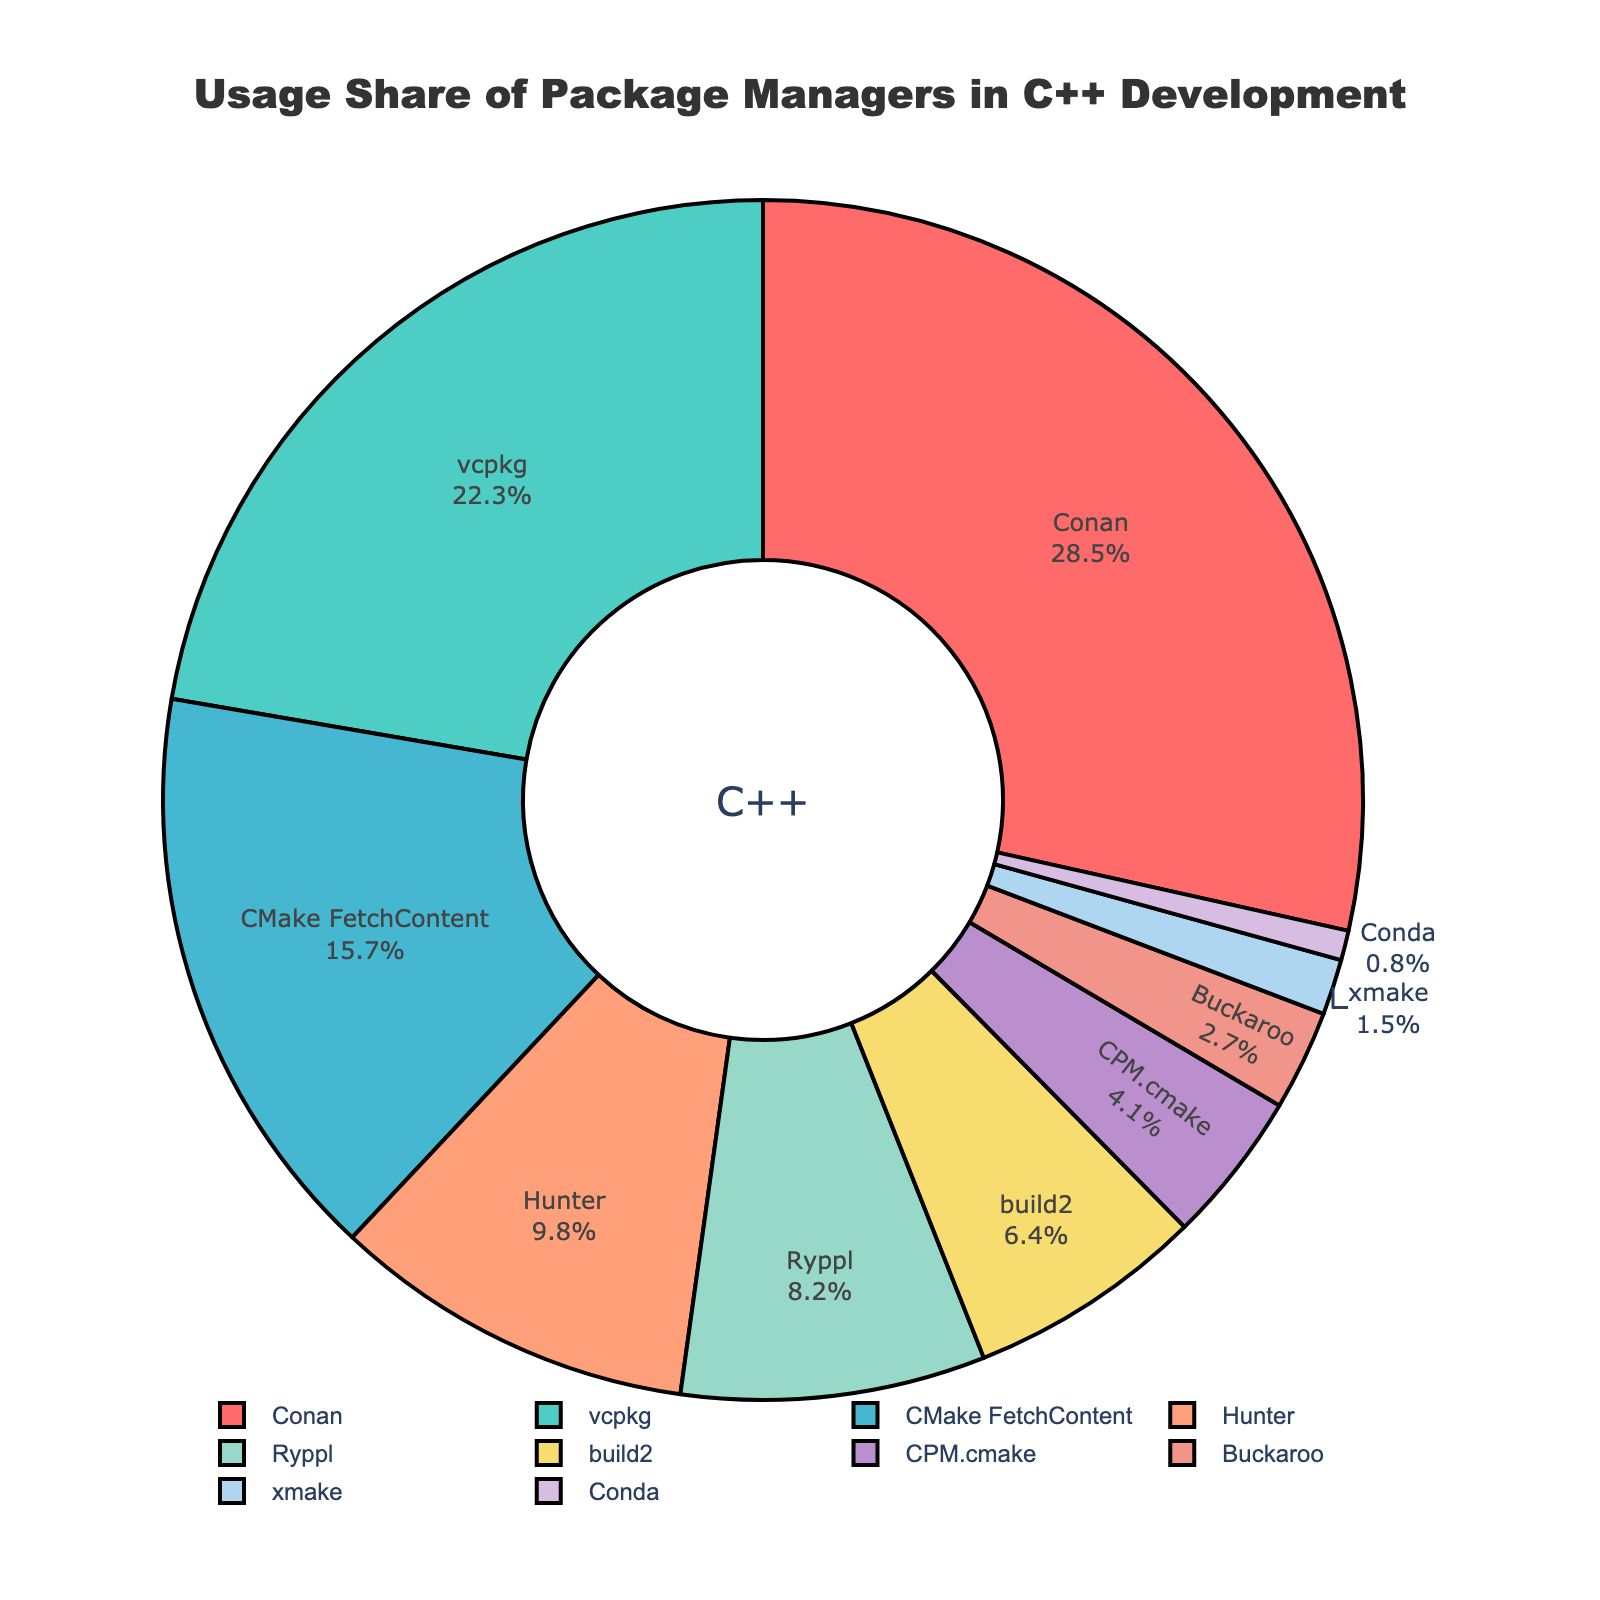Which package manager has the highest usage share? By observing the chart's segments, Conan has the largest share among all the package managers listed.
Answer: Conan Which package manager has a higher usage share: vcpkg or Hunter? Comparing the size of the segments, vcpkg has a larger segment than Hunter.
Answer: vcpkg What is the combined usage share of Conan and vcpkg? Summing the individual usage shares: Conan (28.5) + vcpkg (22.3) = 50.8%
Answer: 50.8% How many package managers have a usage share above 10%? By examining the chart's segments, there are three: Conan (28.5%), vcpkg (22.3%), and CMake FetchContent (15.7%).
Answer: 3 What is the difference in usage share between build2 and Ryppl? Subtracting build2's share from Ryppl's share: 8.2% - 6.4% = 1.8%
Answer: 1.8% Which color represents the package manager with the lowest usage share? By identifying the smallest segment, Conda has the lowest usage share, which is represented by a color close to violet.
Answer: Violet How does the usage share of CPM.cmake compare to that of xmake? CPM.cmake has a higher usage share (4.1%) compared to xmake (1.5%).
Answer: CPM.cmake has a higher share Is the usage share of Hunter closer to vcpkg's share or CMake FetchContent's share? Hunter's 9.8% is closer to CMake FetchContent's 15.7% than to vcpkg's 22.3%.
Answer: CMake FetchContent's share What portion of the chart is represented by package managers with less than 5% usage share each? Summing the shares of individual managers under 5%: CPM.cmake (4.1%) + Buckaroo (2.7%) + xmake (1.5%) + Conda (0.8%) = 9.1%
Answer: 9.1% Which package manager is indicated by the color closest to green? By identifying color codes, vcpkg’s segment is closest to green.
Answer: vcpkg 